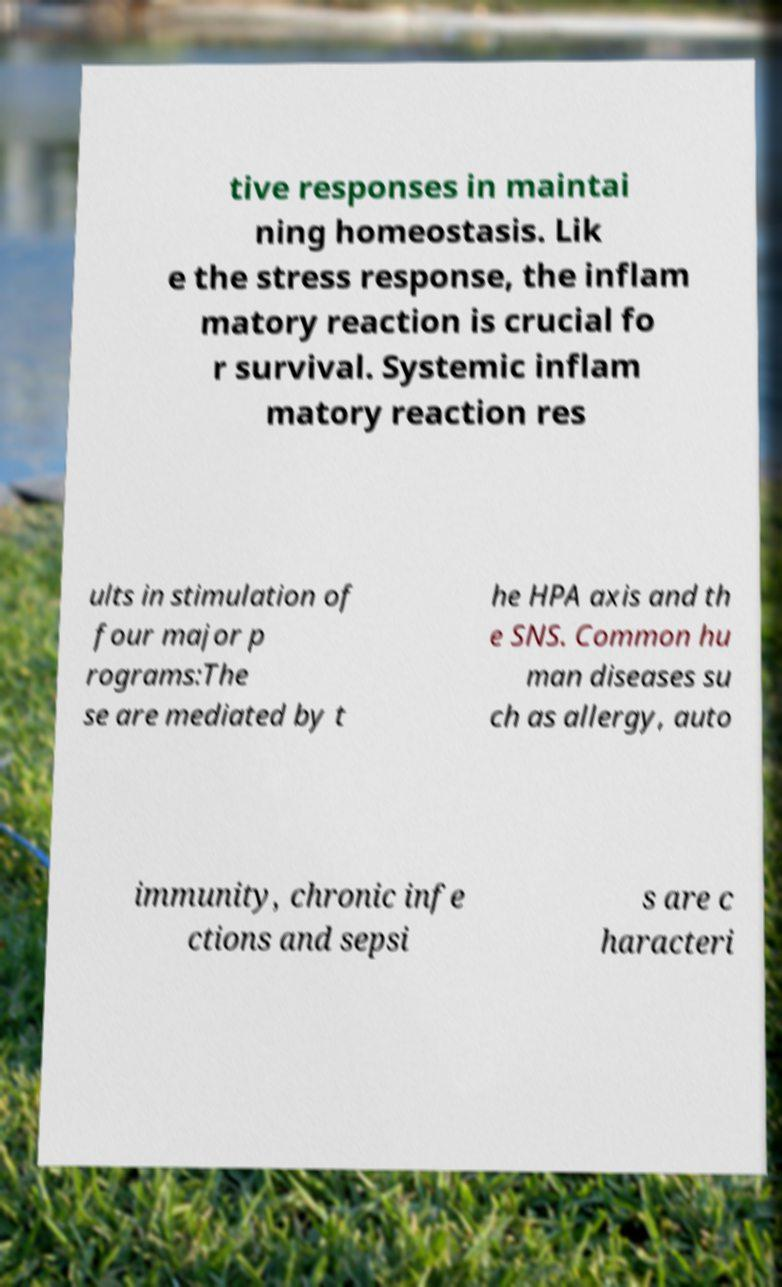I need the written content from this picture converted into text. Can you do that? tive responses in maintai ning homeostasis. Lik e the stress response, the inflam matory reaction is crucial fo r survival. Systemic inflam matory reaction res ults in stimulation of four major p rograms:The se are mediated by t he HPA axis and th e SNS. Common hu man diseases su ch as allergy, auto immunity, chronic infe ctions and sepsi s are c haracteri 